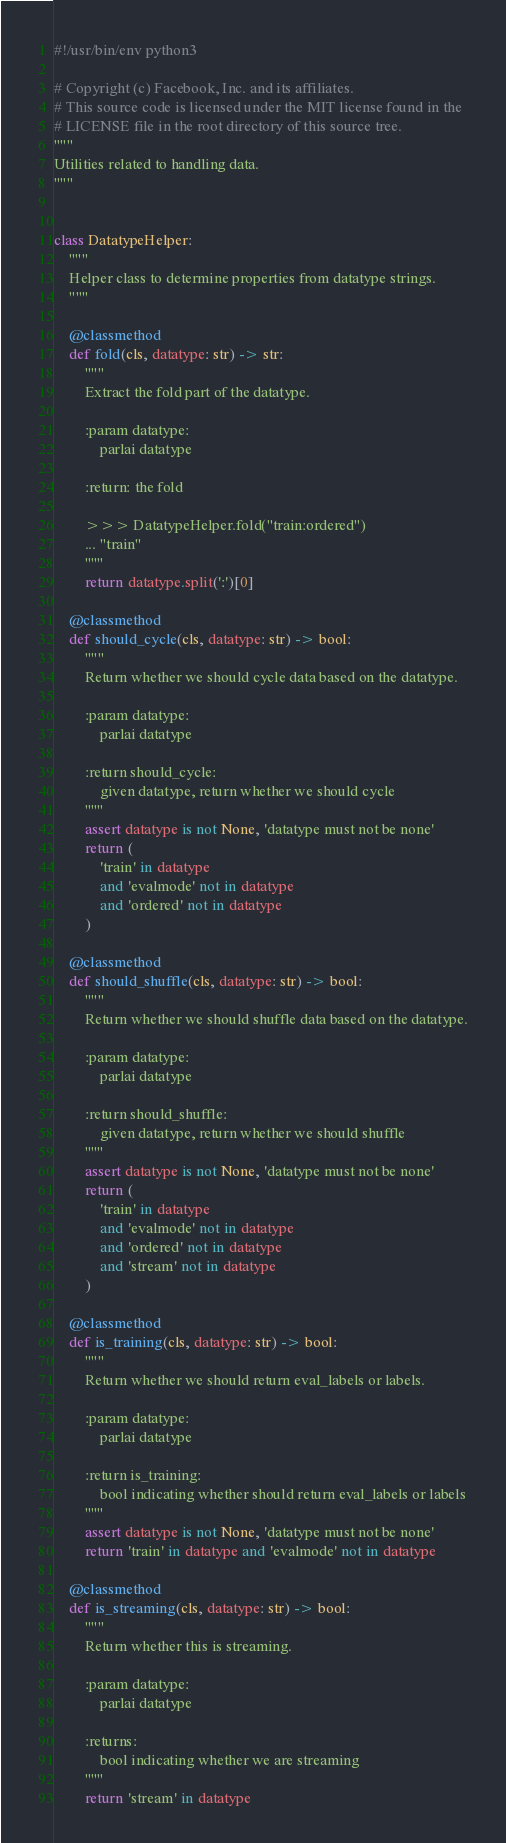Convert code to text. <code><loc_0><loc_0><loc_500><loc_500><_Python_>#!/usr/bin/env python3

# Copyright (c) Facebook, Inc. and its affiliates.
# This source code is licensed under the MIT license found in the
# LICENSE file in the root directory of this source tree.
"""
Utilities related to handling data.
"""


class DatatypeHelper:
    """
    Helper class to determine properties from datatype strings.
    """

    @classmethod
    def fold(cls, datatype: str) -> str:
        """
        Extract the fold part of the datatype.

        :param datatype:
            parlai datatype

        :return: the fold

        >>> DatatypeHelper.fold("train:ordered")
        ... "train"
        """
        return datatype.split(':')[0]

    @classmethod
    def should_cycle(cls, datatype: str) -> bool:
        """
        Return whether we should cycle data based on the datatype.

        :param datatype:
            parlai datatype

        :return should_cycle:
            given datatype, return whether we should cycle
        """
        assert datatype is not None, 'datatype must not be none'
        return (
            'train' in datatype
            and 'evalmode' not in datatype
            and 'ordered' not in datatype
        )

    @classmethod
    def should_shuffle(cls, datatype: str) -> bool:
        """
        Return whether we should shuffle data based on the datatype.

        :param datatype:
            parlai datatype

        :return should_shuffle:
            given datatype, return whether we should shuffle
        """
        assert datatype is not None, 'datatype must not be none'
        return (
            'train' in datatype
            and 'evalmode' not in datatype
            and 'ordered' not in datatype
            and 'stream' not in datatype
        )

    @classmethod
    def is_training(cls, datatype: str) -> bool:
        """
        Return whether we should return eval_labels or labels.

        :param datatype:
            parlai datatype

        :return is_training:
            bool indicating whether should return eval_labels or labels
        """
        assert datatype is not None, 'datatype must not be none'
        return 'train' in datatype and 'evalmode' not in datatype

    @classmethod
    def is_streaming(cls, datatype: str) -> bool:
        """
        Return whether this is streaming.

        :param datatype:
            parlai datatype

        :returns:
            bool indicating whether we are streaming
        """
        return 'stream' in datatype
</code> 